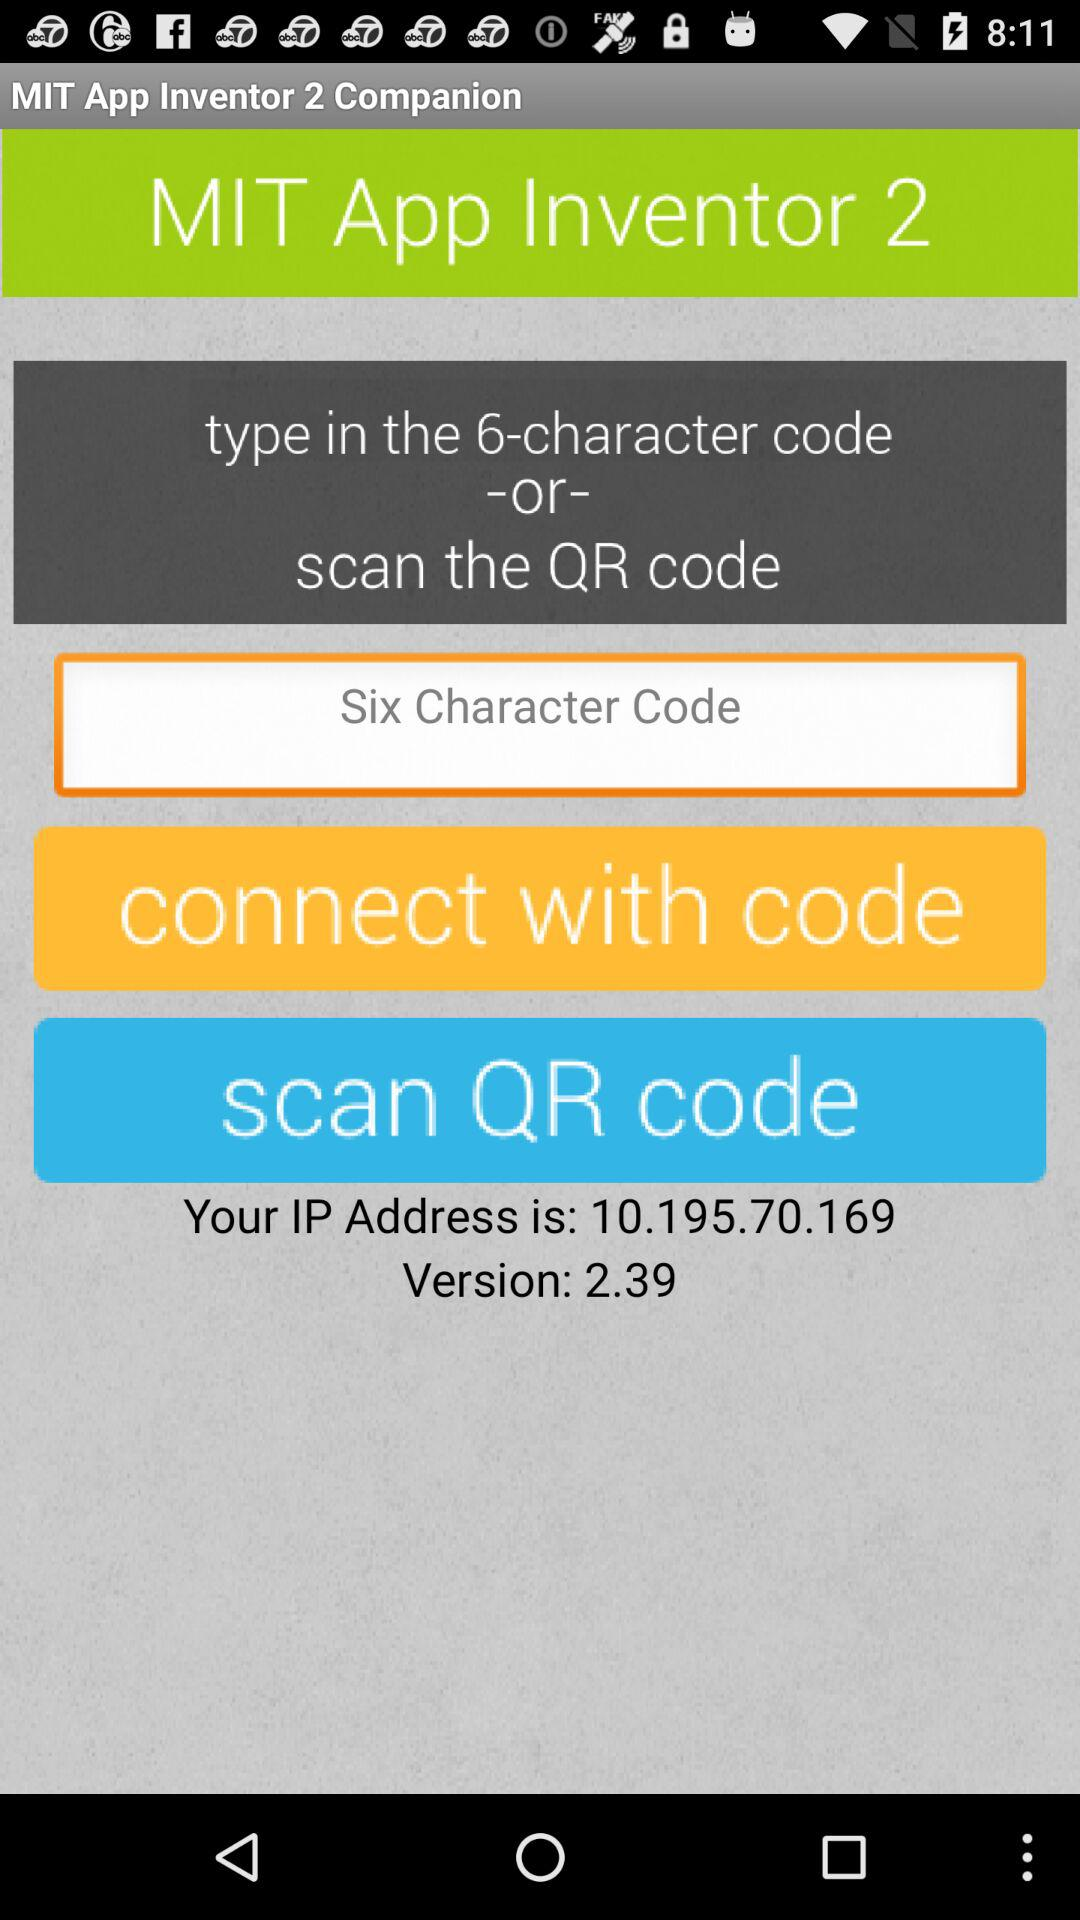How many characters should be there in a code? There should be 6 characters in a code. 